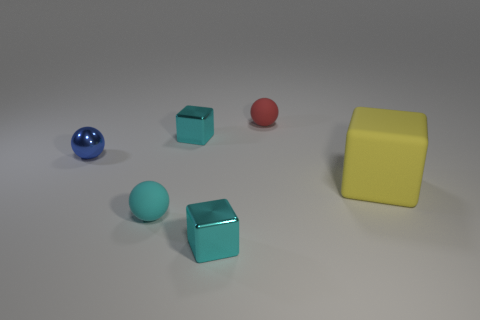Are there more small cyan matte objects than tiny matte objects?
Your answer should be compact. No. There is a object that is on the right side of the tiny matte object that is behind the small blue shiny sphere behind the small cyan rubber object; what is its shape?
Provide a short and direct response. Cube. Are the object to the right of the red object and the cyan thing that is behind the blue object made of the same material?
Your response must be concise. No. What shape is the yellow object that is the same material as the red ball?
Offer a terse response. Cube. Is there anything else of the same color as the large matte block?
Give a very brief answer. No. What number of tiny objects are there?
Your answer should be very brief. 5. The large yellow block behind the small matte thing that is in front of the tiny red rubber thing is made of what material?
Your response must be concise. Rubber. What color is the small rubber object on the right side of the object in front of the cyan ball that is in front of the tiny blue shiny object?
Your answer should be compact. Red. Is the color of the big rubber cube the same as the metallic sphere?
Your response must be concise. No. How many red rubber balls have the same size as the cyan rubber thing?
Give a very brief answer. 1. 